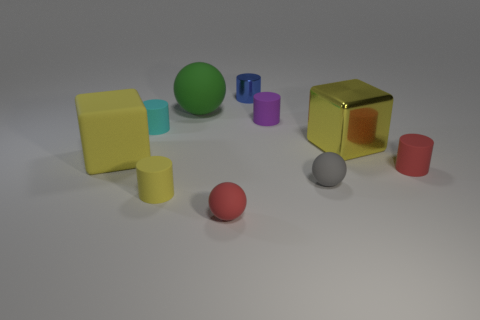Subtract all tiny balls. How many balls are left? 1 Subtract all cyan cylinders. How many cylinders are left? 4 Subtract all brown balls. Subtract all red cylinders. How many balls are left? 3 Subtract all blocks. How many objects are left? 8 Add 4 large yellow things. How many large yellow things are left? 6 Add 6 purple cylinders. How many purple cylinders exist? 7 Subtract 1 gray spheres. How many objects are left? 9 Subtract all cyan rubber blocks. Subtract all big yellow things. How many objects are left? 8 